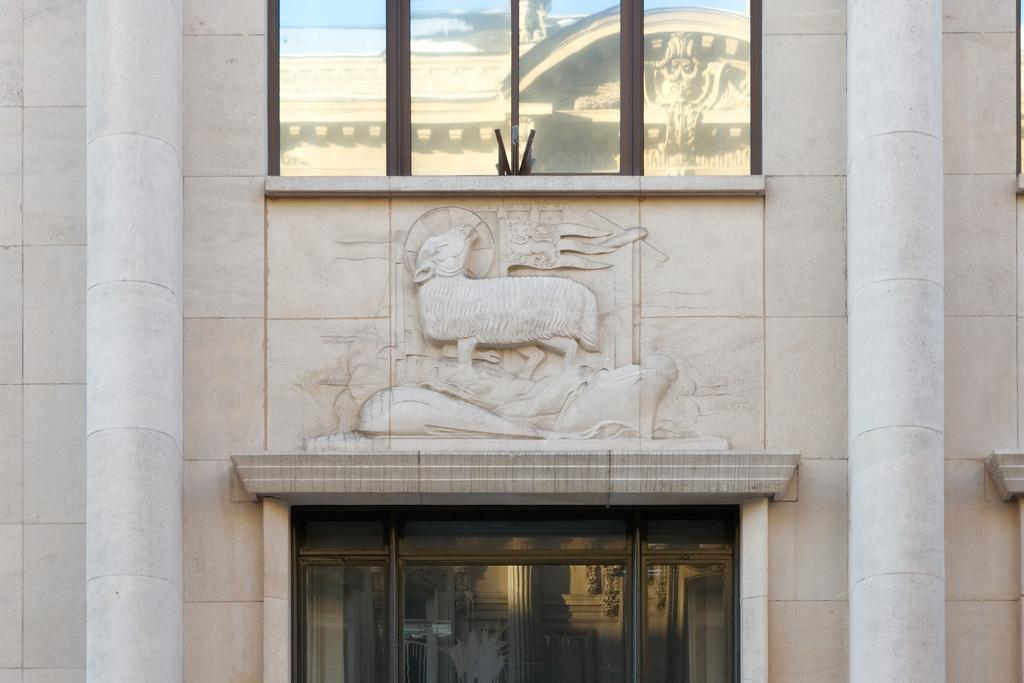What type of structure is present in the image? There is a building in the picture. What can be seen on the wall of the building? There is stone carving on the wall of the building. What type of windows are present on the wall of the building? There are glass windows on the wall of the building. Can you tell me where your aunt is pointing in the image? There is no reference to an aunt or any pointing in the image, so it's not possible to answer that question. 